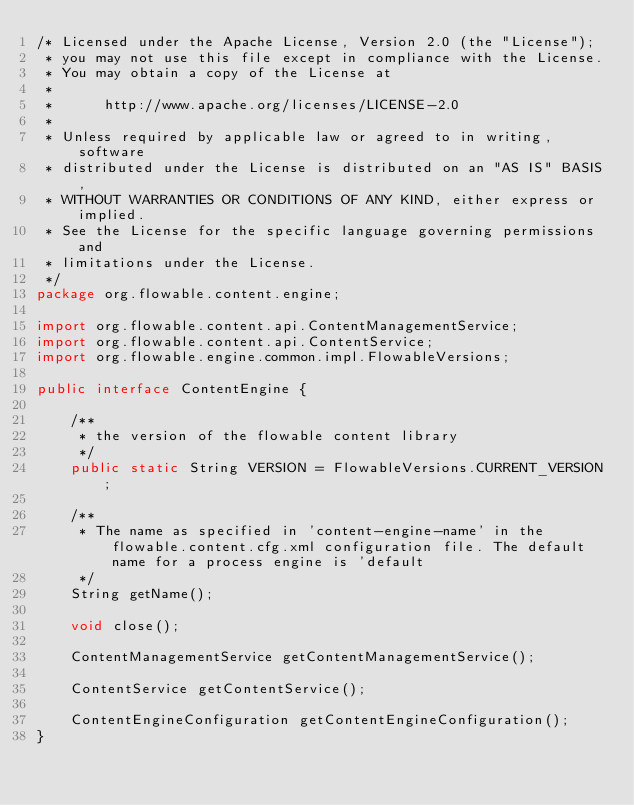Convert code to text. <code><loc_0><loc_0><loc_500><loc_500><_Java_>/* Licensed under the Apache License, Version 2.0 (the "License");
 * you may not use this file except in compliance with the License.
 * You may obtain a copy of the License at
 * 
 *      http://www.apache.org/licenses/LICENSE-2.0
 * 
 * Unless required by applicable law or agreed to in writing, software
 * distributed under the License is distributed on an "AS IS" BASIS,
 * WITHOUT WARRANTIES OR CONDITIONS OF ANY KIND, either express or implied.
 * See the License for the specific language governing permissions and
 * limitations under the License.
 */
package org.flowable.content.engine;

import org.flowable.content.api.ContentManagementService;
import org.flowable.content.api.ContentService;
import org.flowable.engine.common.impl.FlowableVersions;

public interface ContentEngine {

    /**
     * the version of the flowable content library
     */
    public static String VERSION = FlowableVersions.CURRENT_VERSION;

    /**
     * The name as specified in 'content-engine-name' in the flowable.content.cfg.xml configuration file. The default name for a process engine is 'default
     */
    String getName();

    void close();

    ContentManagementService getContentManagementService();

    ContentService getContentService();

    ContentEngineConfiguration getContentEngineConfiguration();
}
</code> 